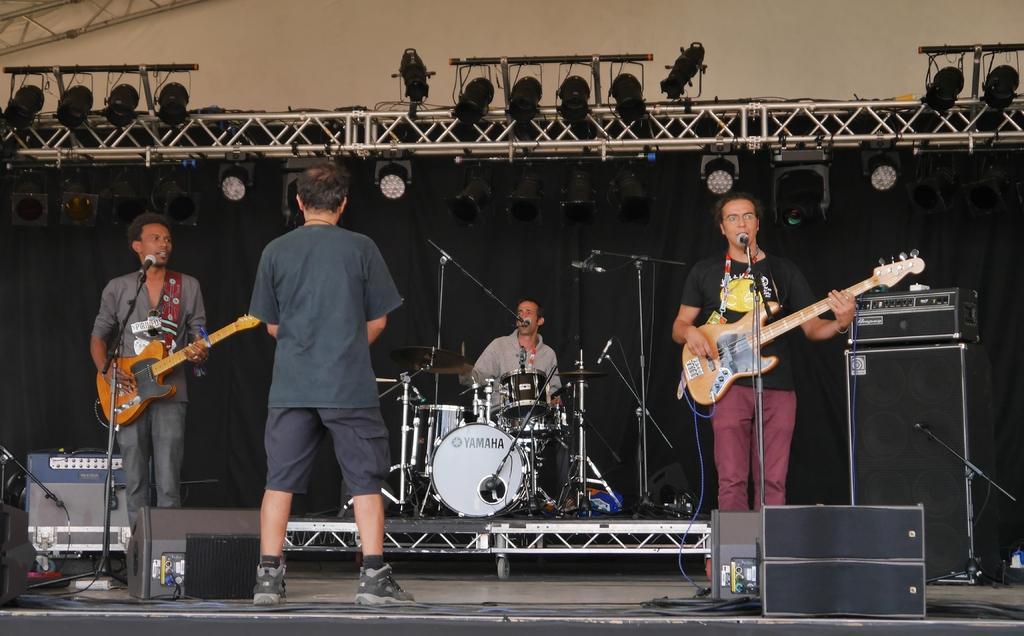Describe this image in one or two sentences. In this image we can see three persons performing on a stage. They are playing a guitar, playing a snare drum and singing on a microphone. There is a person standing in the center on the stage. 